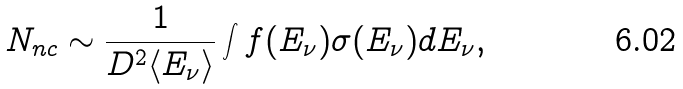<formula> <loc_0><loc_0><loc_500><loc_500>N _ { n c } \sim \frac { 1 } { D ^ { 2 } \langle E _ { \nu } \rangle } \int f ( E _ { \nu } ) \sigma ( E _ { \nu } ) d E _ { \nu } ,</formula> 